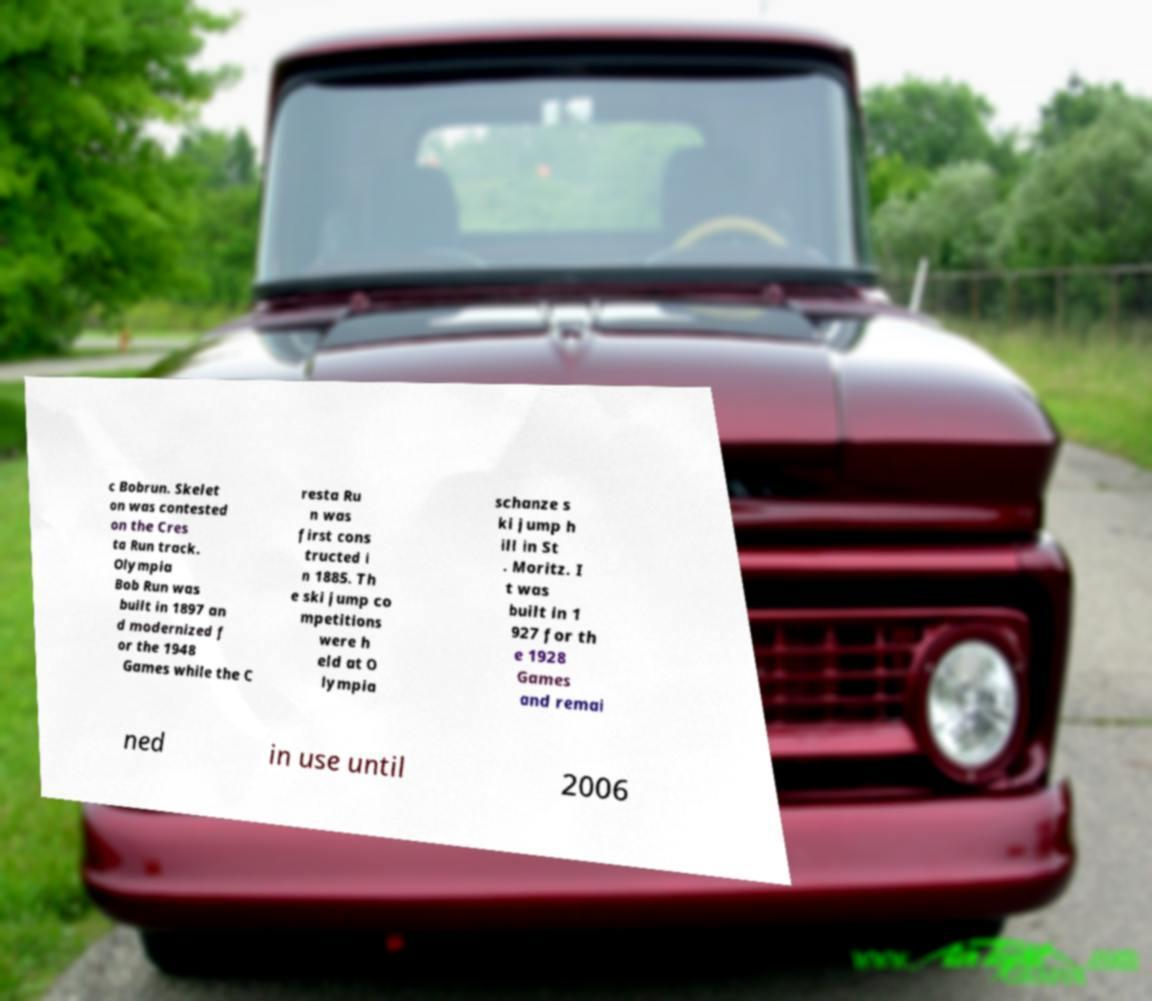For documentation purposes, I need the text within this image transcribed. Could you provide that? c Bobrun. Skelet on was contested on the Cres ta Run track. Olympia Bob Run was built in 1897 an d modernized f or the 1948 Games while the C resta Ru n was first cons tructed i n 1885. Th e ski jump co mpetitions were h eld at O lympia schanze s ki jump h ill in St . Moritz. I t was built in 1 927 for th e 1928 Games and remai ned in use until 2006 